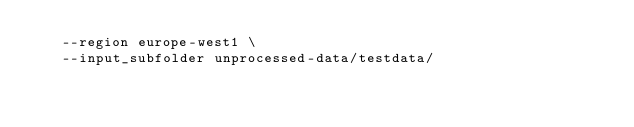Convert code to text. <code><loc_0><loc_0><loc_500><loc_500><_Bash_>   --region europe-west1 \
   --input_subfolder unprocessed-data/testdata/
</code> 